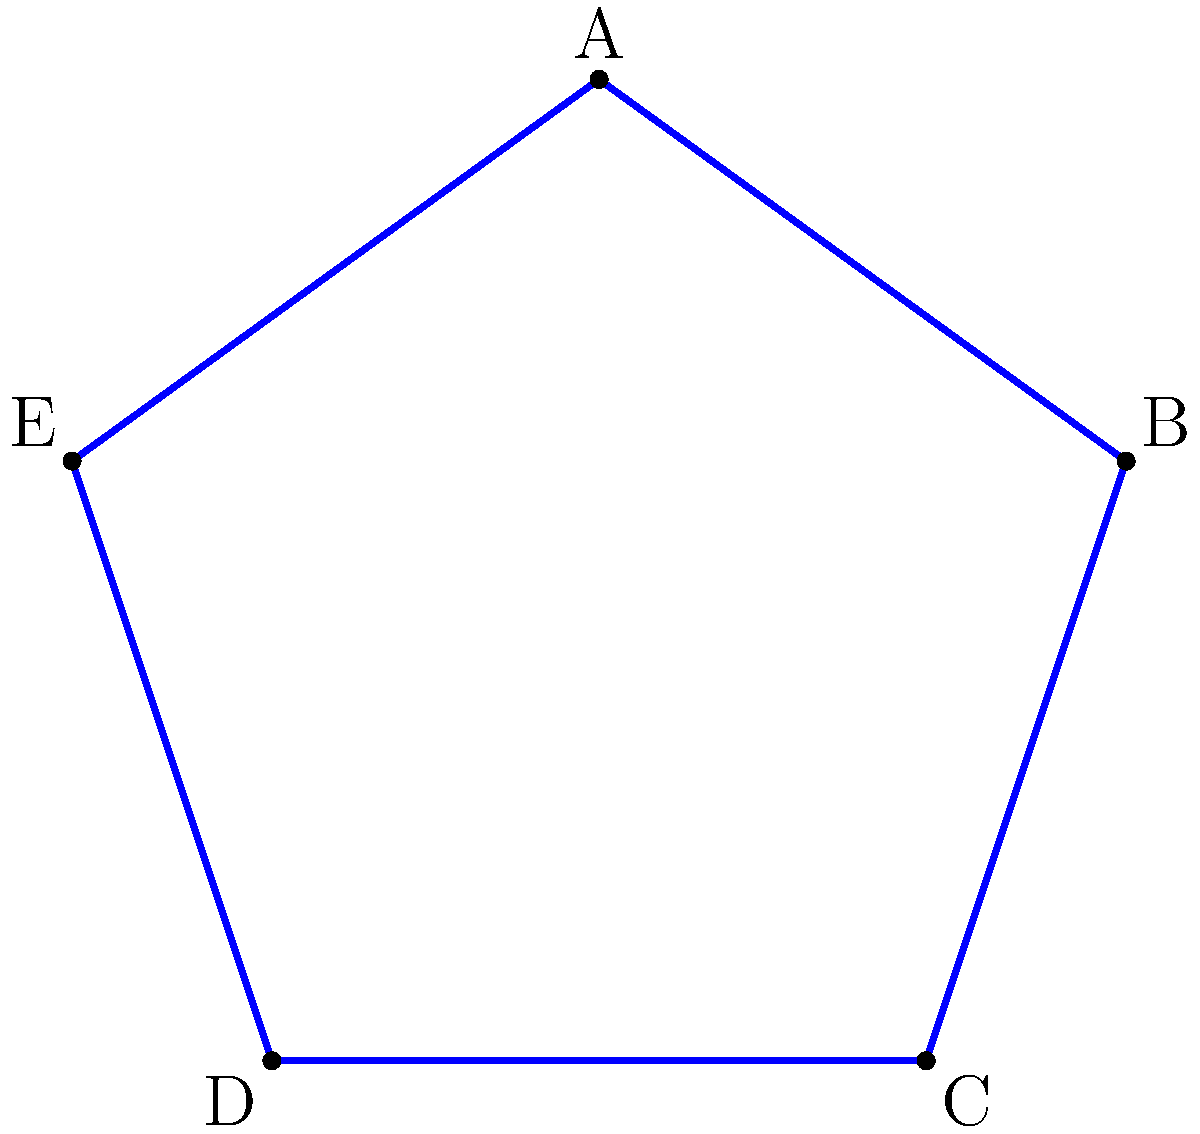During an aerial display, you create a star-shaped pattern with your flight path as shown in the diagram. If the distance between each consecutive point of the star is 5 km, what is the total area enclosed by this flight path? Round your answer to the nearest square kilometer. To find the area of the star-shaped pattern, we can follow these steps:

1) First, we need to recognize that this star shape is made up of a pentagon in the center with five isosceles triangles protruding from each side.

2) The area of a regular pentagon with side length $s$ is given by the formula:

   $A_{pentagon} = \frac{1}{4}\sqrt{25+10\sqrt{5}}s^2$

3) For each isosceles triangle, we need to find its height. If we split it down the middle, we get a right triangle with hypotenuse 5 km and base 2.5 km. Using the Pythagorean theorem:

   $h^2 + (2.5)^2 = 5^2$
   $h^2 = 25 - 6.25 = 18.75$
   $h = \sqrt{18.75} \approx 4.33$ km

4) The area of each isosceles triangle is thus:

   $A_{triangle} = \frac{1}{2} * 5 * 4.33 = 10.825$ km²

5) To find the side length of the inner pentagon, we can use the fact that it's made up of the bases of the isosceles triangles. So its side length is 2.5 km.

6) Now we can calculate the area of the inner pentagon:

   $A_{pentagon} = \frac{1}{4}\sqrt{25+10\sqrt{5}}(2.5)^2 \approx 11.881$ km²

7) The total area is the sum of the pentagon and the five triangles:

   $A_{total} = 11.881 + 5 * 10.825 = 66.006$ km²

8) Rounding to the nearest square kilometer gives us 66 km².
Answer: 66 km² 